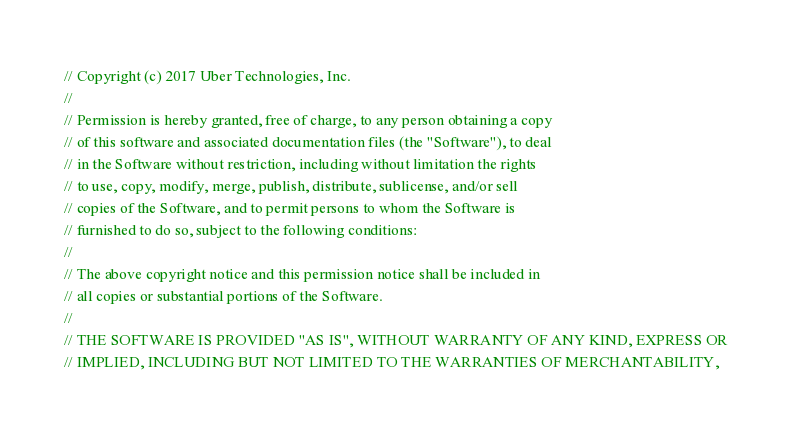Convert code to text. <code><loc_0><loc_0><loc_500><loc_500><_Go_>// Copyright (c) 2017 Uber Technologies, Inc.
//
// Permission is hereby granted, free of charge, to any person obtaining a copy
// of this software and associated documentation files (the "Software"), to deal
// in the Software without restriction, including without limitation the rights
// to use, copy, modify, merge, publish, distribute, sublicense, and/or sell
// copies of the Software, and to permit persons to whom the Software is
// furnished to do so, subject to the following conditions:
//
// The above copyright notice and this permission notice shall be included in
// all copies or substantial portions of the Software.
//
// THE SOFTWARE IS PROVIDED "AS IS", WITHOUT WARRANTY OF ANY KIND, EXPRESS OR
// IMPLIED, INCLUDING BUT NOT LIMITED TO THE WARRANTIES OF MERCHANTABILITY,</code> 